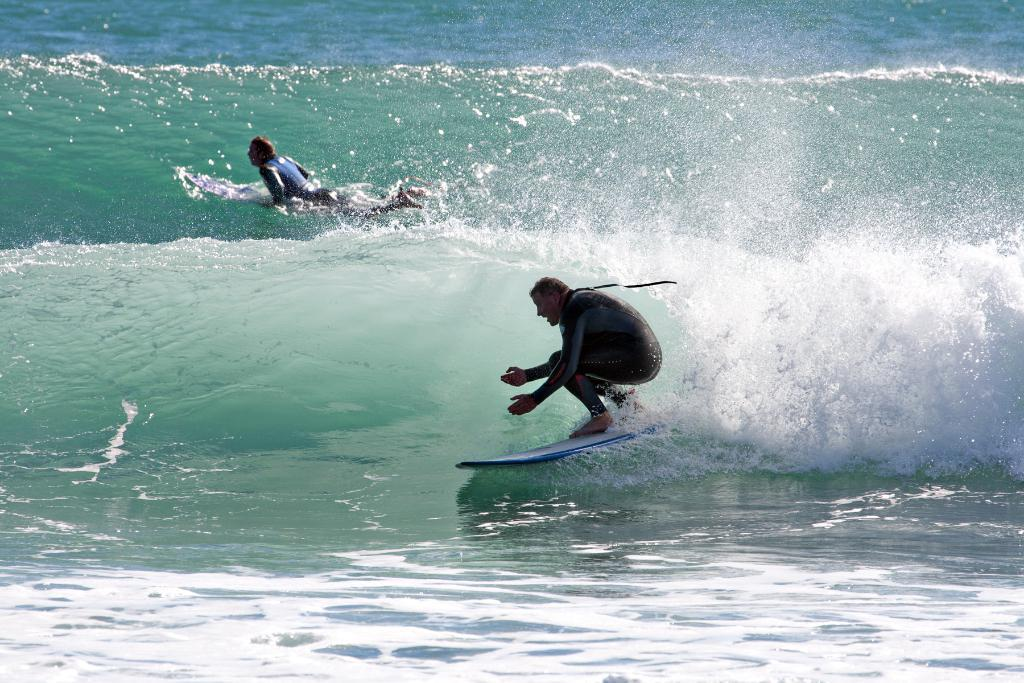Where was the image taken? The image was clicked outside the city. What are the two persons in the image doing? The two persons are surfing in the image. What are they using to surf? They are surfing on a surfboard. What can be observed about the water body in the image? There are ripples in the water body. What type of soda is being served at the farm in the image? There is no soda or farm present in the image; it features two persons surfing on a surfboard in a water body. 